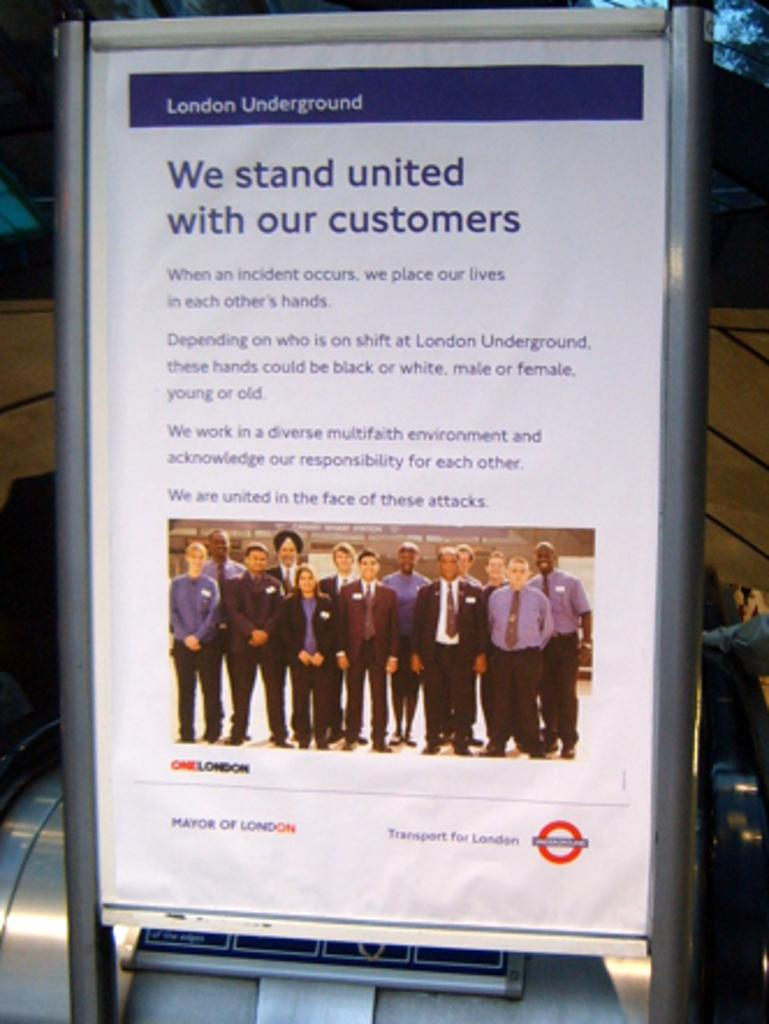<image>
Create a compact narrative representing the image presented. The London Underground placard lets you know that they stand with their customers. 